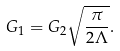Convert formula to latex. <formula><loc_0><loc_0><loc_500><loc_500>G _ { 1 } = G _ { 2 } \sqrt { \frac { \pi } { 2 \Lambda } } .</formula> 